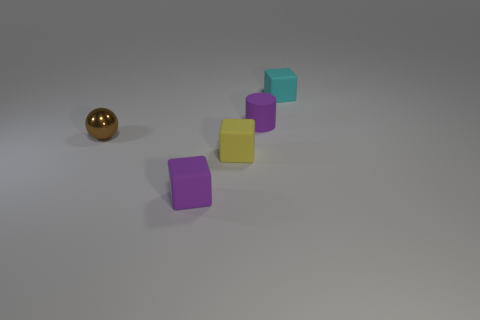What size is the purple rubber thing that is right of the small purple matte object that is in front of the tiny brown shiny object?
Give a very brief answer. Small. There is a small rubber block behind the tiny metal sphere; does it have the same color as the small object that is in front of the small yellow cube?
Your answer should be very brief. No. What is the color of the tiny rubber object that is both to the left of the cyan object and on the right side of the yellow thing?
Give a very brief answer. Purple. How many other things are there of the same shape as the yellow object?
Provide a short and direct response. 2. What is the color of the cylinder that is the same size as the brown object?
Ensure brevity in your answer.  Purple. There is a small matte block that is behind the small brown shiny sphere; what color is it?
Offer a terse response. Cyan. Are there any small cyan cubes that are to the right of the tiny cube that is behind the brown thing?
Offer a terse response. No. Is the shape of the small cyan rubber thing the same as the purple object that is in front of the small purple rubber cylinder?
Give a very brief answer. Yes. What is the size of the rubber cube that is both on the left side of the tiny cyan thing and behind the purple matte block?
Give a very brief answer. Small. Are there any small cylinders made of the same material as the cyan block?
Offer a terse response. Yes. 